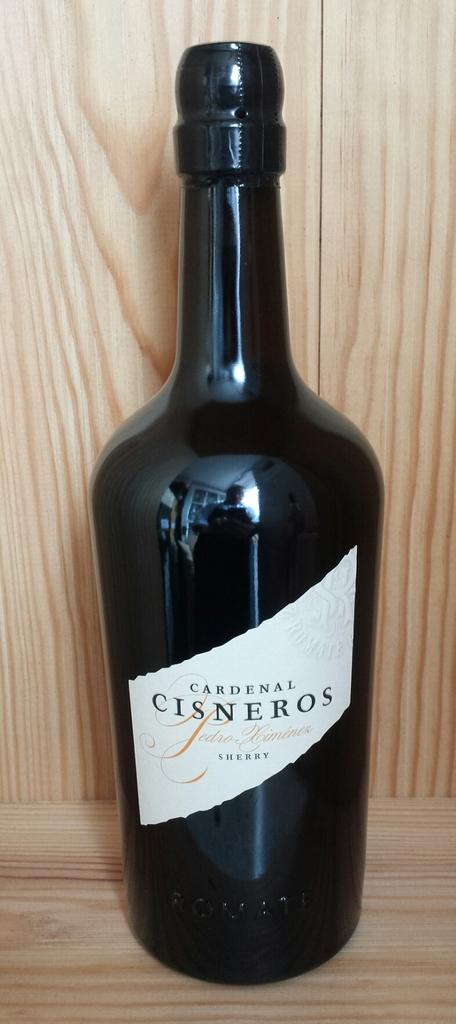<image>
Share a concise interpretation of the image provided. The black bottle of Sherry has a white lable that appears torn. 